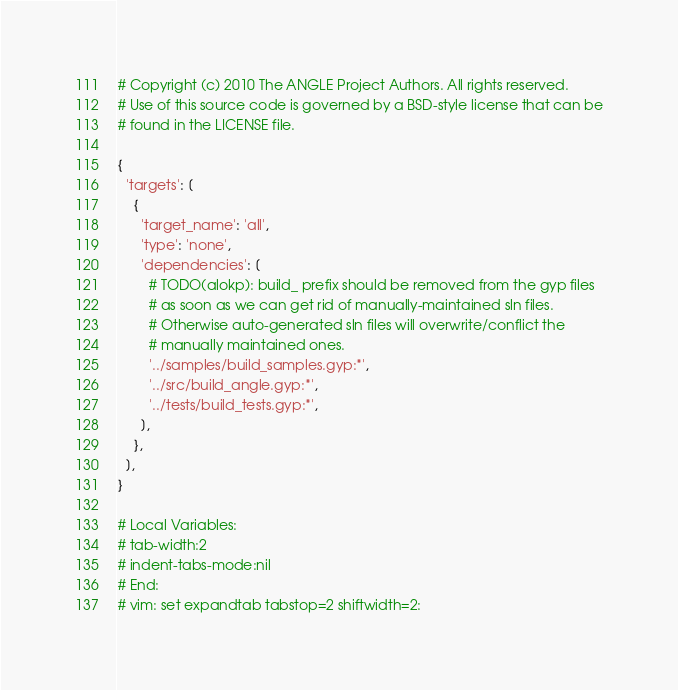<code> <loc_0><loc_0><loc_500><loc_500><_Python_># Copyright (c) 2010 The ANGLE Project Authors. All rights reserved.
# Use of this source code is governed by a BSD-style license that can be
# found in the LICENSE file.

{
  'targets': [
    {
      'target_name': 'all',
      'type': 'none',
      'dependencies': [
        # TODO(alokp): build_ prefix should be removed from the gyp files
        # as soon as we can get rid of manually-maintained sln files.
        # Otherwise auto-generated sln files will overwrite/conflict the
        # manually maintained ones.
        '../samples/build_samples.gyp:*',
        '../src/build_angle.gyp:*',
        '../tests/build_tests.gyp:*',
      ],
    },
  ],
}

# Local Variables:
# tab-width:2
# indent-tabs-mode:nil
# End:
# vim: set expandtab tabstop=2 shiftwidth=2:
</code> 